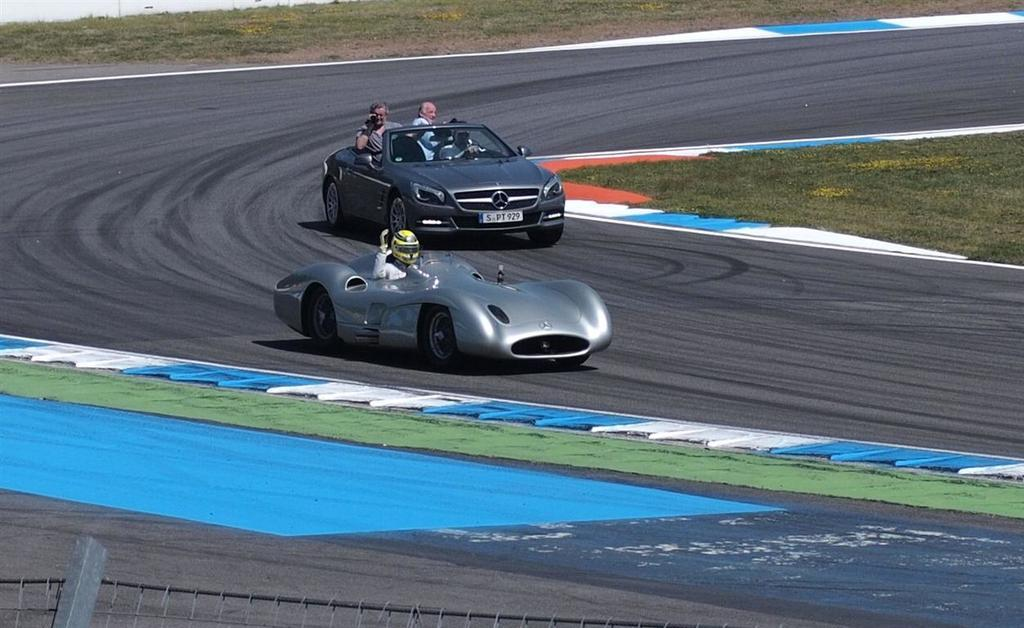What is happening with the cars in the image? There are two cars moving on the road in the image. How many people are in each car? Three people are sitting in one car, and one person is sitting in the other car. What can be seen in the background of the image? There is grass visible in the image. What type of prose is being read by the person sitting in the car? There is no indication in the image that anyone is reading prose or any other type of literature. 